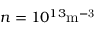Convert formula to latex. <formula><loc_0><loc_0><loc_500><loc_500>n = 1 0 ^ { 1 3 } m ^ { - 3 }</formula> 